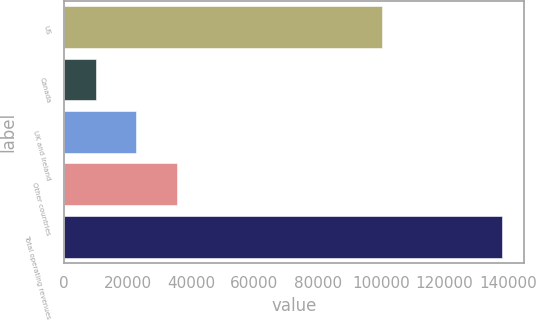<chart> <loc_0><loc_0><loc_500><loc_500><bar_chart><fcel>US<fcel>Canada<fcel>UK and Ireland<fcel>Other countries<fcel>Total operating revenues<nl><fcel>100418<fcel>9974<fcel>22784<fcel>35594<fcel>138074<nl></chart> 